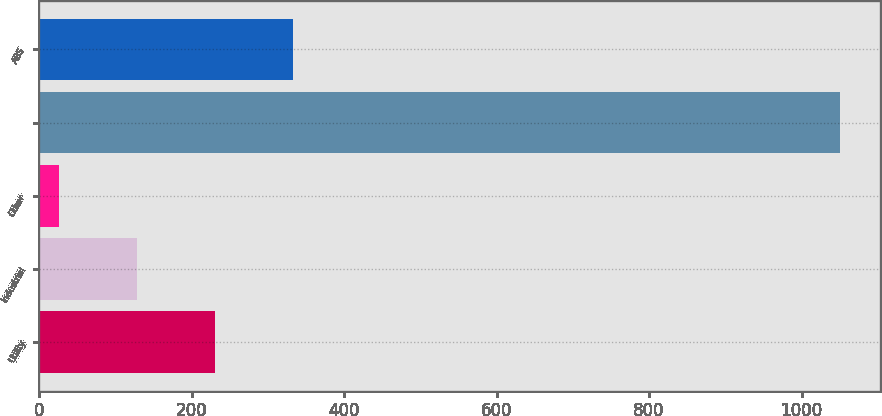Convert chart. <chart><loc_0><loc_0><loc_500><loc_500><bar_chart><fcel>Utility<fcel>Industrial<fcel>Other<fcel>Unnamed: 3<fcel>ABS<nl><fcel>230.8<fcel>128.4<fcel>26<fcel>1050<fcel>333.2<nl></chart> 